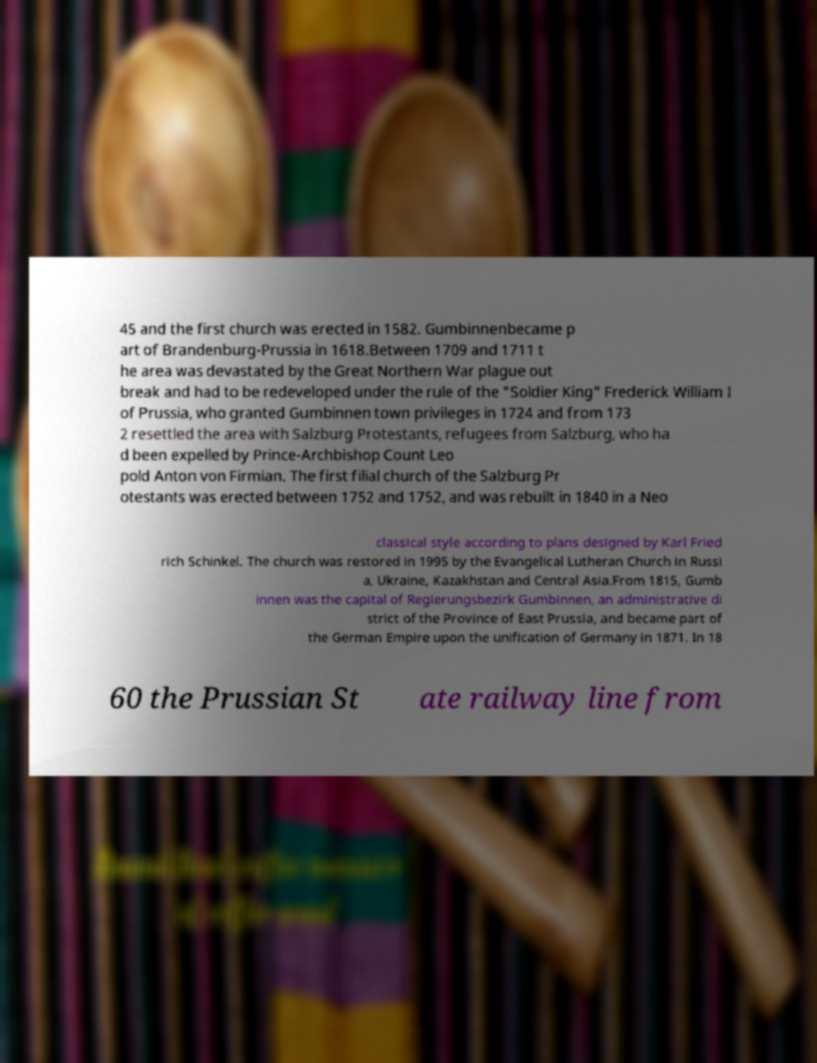Can you read and provide the text displayed in the image?This photo seems to have some interesting text. Can you extract and type it out for me? 45 and the first church was erected in 1582. Gumbinnenbecame p art of Brandenburg-Prussia in 1618.Between 1709 and 1711 t he area was devastated by the Great Northern War plague out break and had to be redeveloped under the rule of the "Soldier King" Frederick William I of Prussia, who granted Gumbinnen town privileges in 1724 and from 173 2 resettled the area with Salzburg Protestants, refugees from Salzburg, who ha d been expelled by Prince-Archbishop Count Leo pold Anton von Firmian. The first filial church of the Salzburg Pr otestants was erected between 1752 and 1752, and was rebuilt in 1840 in a Neo classical style according to plans designed by Karl Fried rich Schinkel. The church was restored in 1995 by the Evangelical Lutheran Church in Russi a, Ukraine, Kazakhstan and Central Asia.From 1815, Gumb innen was the capital of Regierungsbezirk Gumbinnen, an administrative di strict of the Province of East Prussia, and became part of the German Empire upon the unification of Germany in 1871. In 18 60 the Prussian St ate railway line from 